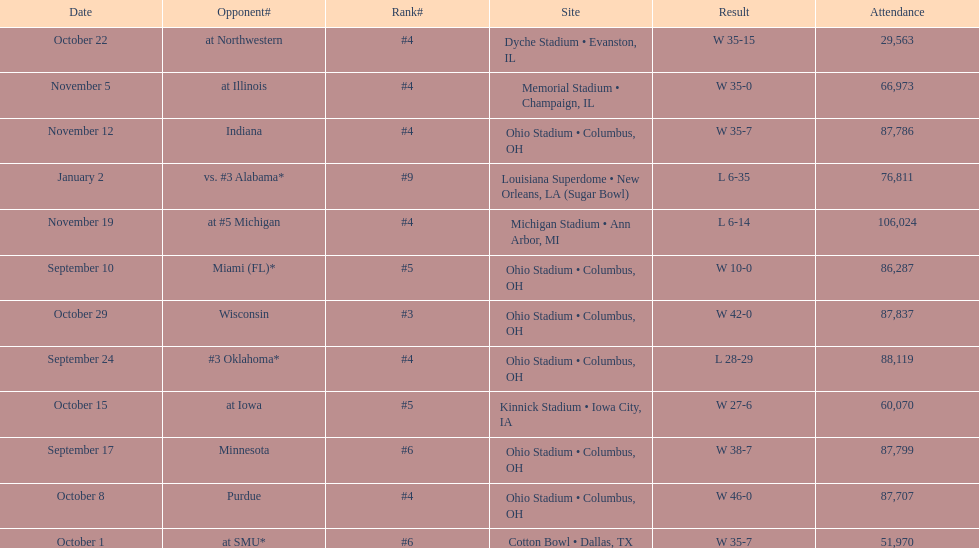What is the difference between the number of wins and the number of losses? 6. 